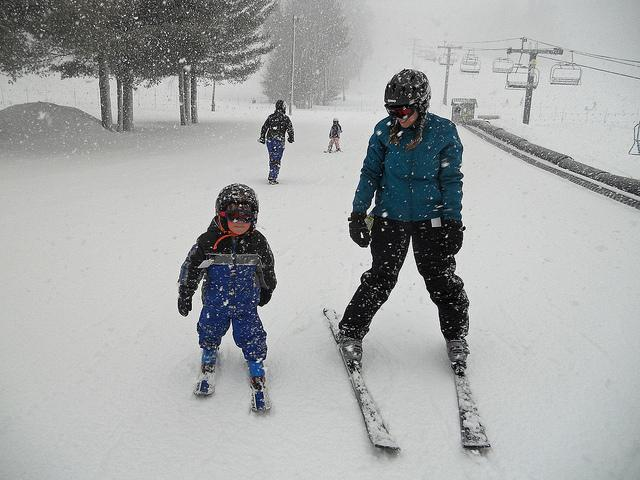What is the contraption on the right used for? Please explain your reasoning. climbing slopes. There person on the right uses the contraption for climbing slopes. 